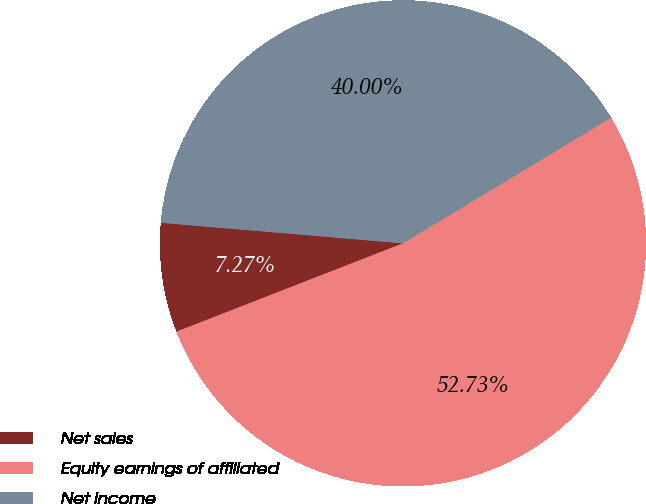Convert chart to OTSL. <chart><loc_0><loc_0><loc_500><loc_500><pie_chart><fcel>Net sales<fcel>Equity earnings of affiliated<fcel>Net income<nl><fcel>7.27%<fcel>52.73%<fcel>40.0%<nl></chart> 